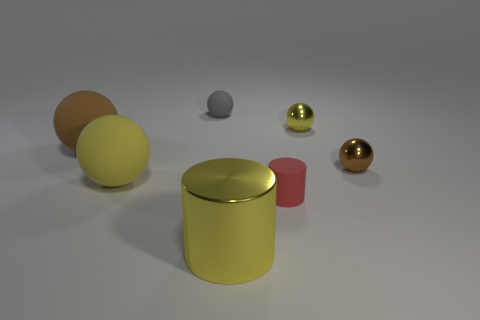Subtract all gray rubber spheres. How many spheres are left? 4 Add 1 big purple metal objects. How many objects exist? 8 Subtract all brown balls. How many balls are left? 3 Subtract 3 balls. How many balls are left? 2 Subtract all balls. How many objects are left? 2 Subtract 0 brown cylinders. How many objects are left? 7 Subtract all cyan balls. Subtract all blue cylinders. How many balls are left? 5 Subtract all red cylinders. How many blue balls are left? 0 Subtract all tiny rubber cylinders. Subtract all tiny matte things. How many objects are left? 4 Add 7 yellow metallic balls. How many yellow metallic balls are left? 8 